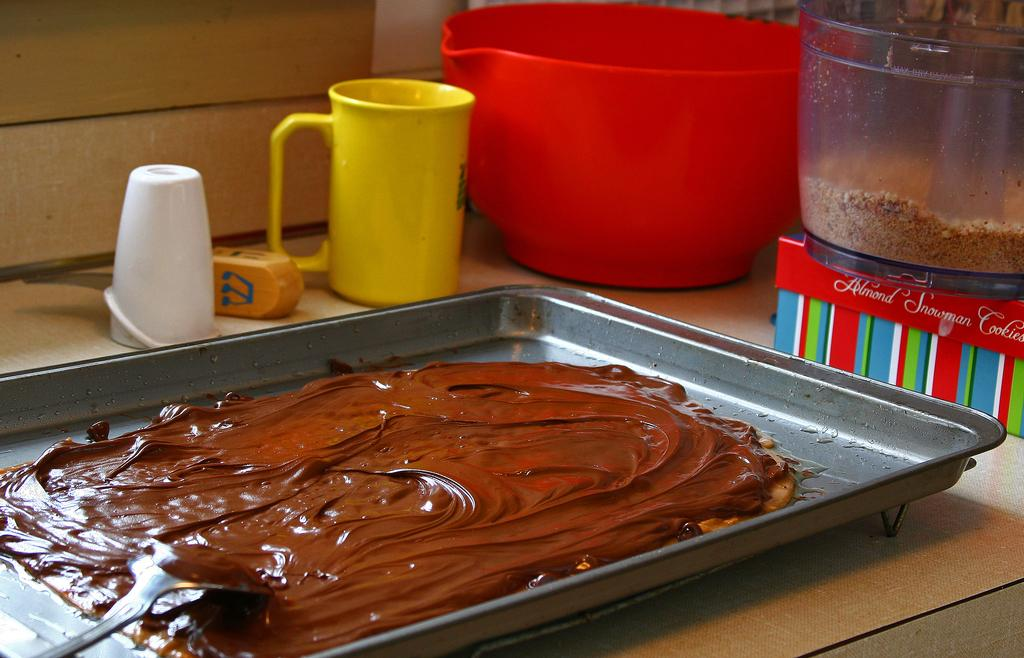What is on the plate in the image? There is melted chocolate on a plate in the image. What utensil is present with the melted chocolate? A spoon is present with the melted chocolate. What can be seen in the background of the image? Vessels, a container, a box, glasses, and a wall are visible in the background of the image. What type of elbow can be seen in the image? There is no elbow present in the image. What role does the wire play in the image? There is no wire present in the image. 